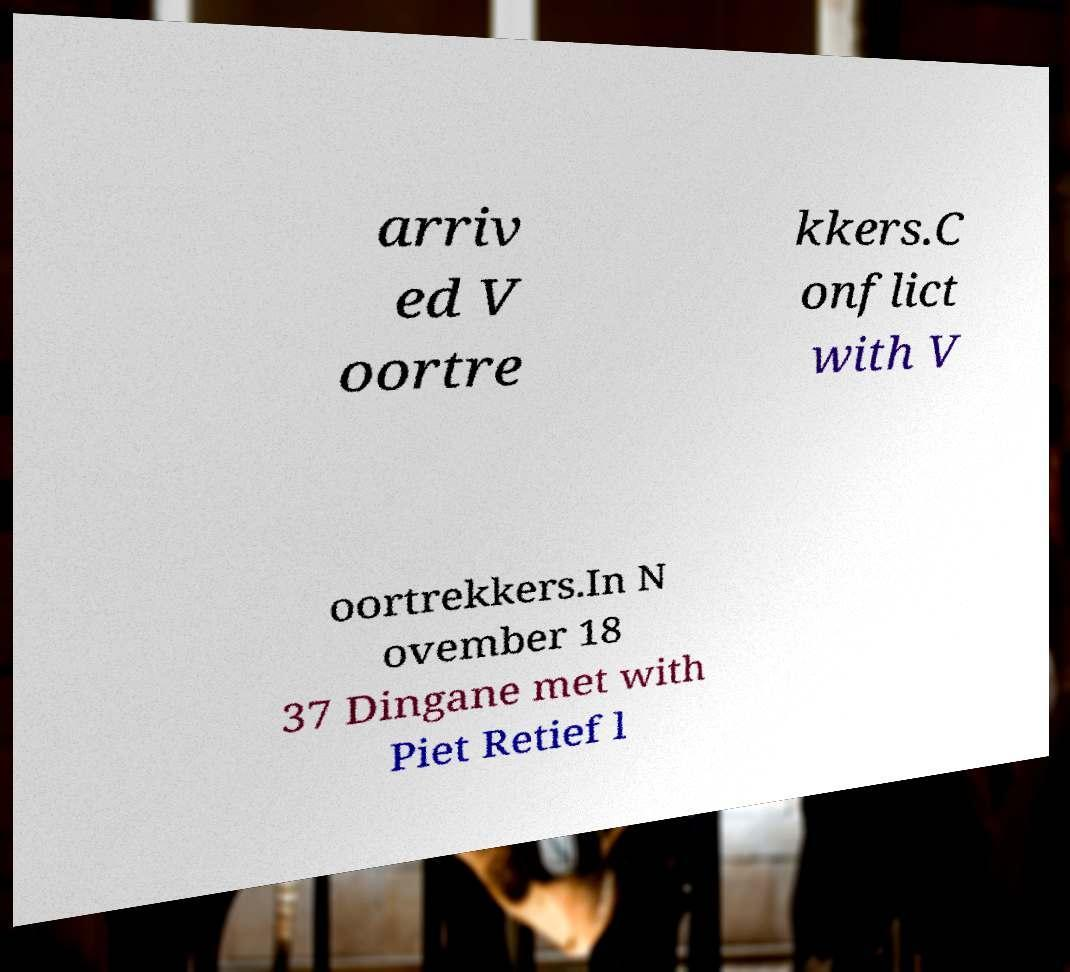What messages or text are displayed in this image? I need them in a readable, typed format. arriv ed V oortre kkers.C onflict with V oortrekkers.In N ovember 18 37 Dingane met with Piet Retief l 